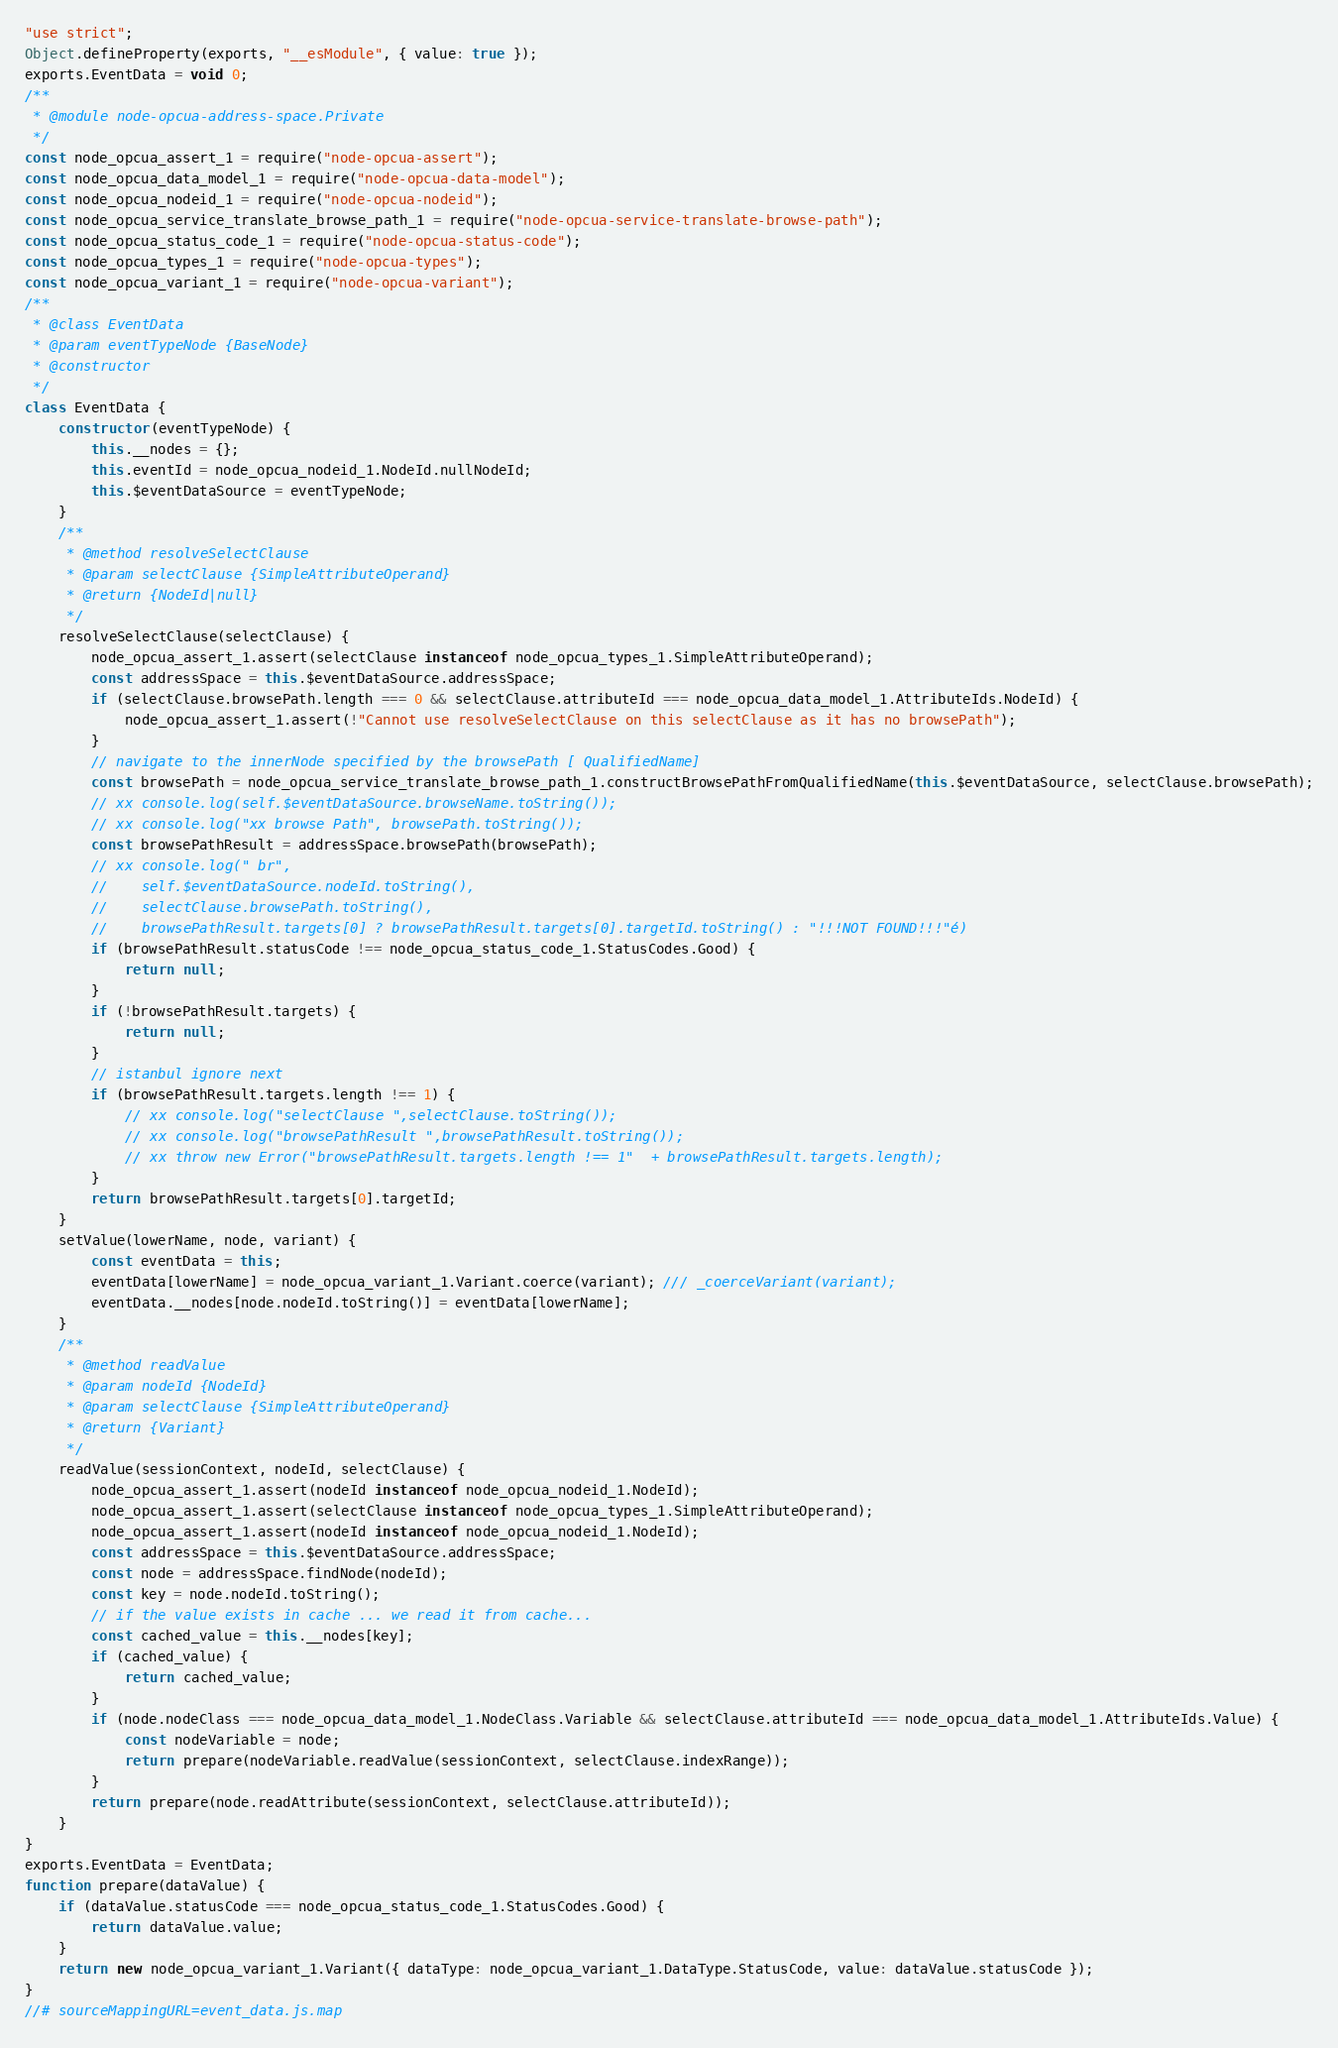Convert code to text. <code><loc_0><loc_0><loc_500><loc_500><_JavaScript_>"use strict";
Object.defineProperty(exports, "__esModule", { value: true });
exports.EventData = void 0;
/**
 * @module node-opcua-address-space.Private
 */
const node_opcua_assert_1 = require("node-opcua-assert");
const node_opcua_data_model_1 = require("node-opcua-data-model");
const node_opcua_nodeid_1 = require("node-opcua-nodeid");
const node_opcua_service_translate_browse_path_1 = require("node-opcua-service-translate-browse-path");
const node_opcua_status_code_1 = require("node-opcua-status-code");
const node_opcua_types_1 = require("node-opcua-types");
const node_opcua_variant_1 = require("node-opcua-variant");
/**
 * @class EventData
 * @param eventTypeNode {BaseNode}
 * @constructor
 */
class EventData {
    constructor(eventTypeNode) {
        this.__nodes = {};
        this.eventId = node_opcua_nodeid_1.NodeId.nullNodeId;
        this.$eventDataSource = eventTypeNode;
    }
    /**
     * @method resolveSelectClause
     * @param selectClause {SimpleAttributeOperand}
     * @return {NodeId|null}
     */
    resolveSelectClause(selectClause) {
        node_opcua_assert_1.assert(selectClause instanceof node_opcua_types_1.SimpleAttributeOperand);
        const addressSpace = this.$eventDataSource.addressSpace;
        if (selectClause.browsePath.length === 0 && selectClause.attributeId === node_opcua_data_model_1.AttributeIds.NodeId) {
            node_opcua_assert_1.assert(!"Cannot use resolveSelectClause on this selectClause as it has no browsePath");
        }
        // navigate to the innerNode specified by the browsePath [ QualifiedName]
        const browsePath = node_opcua_service_translate_browse_path_1.constructBrowsePathFromQualifiedName(this.$eventDataSource, selectClause.browsePath);
        // xx console.log(self.$eventDataSource.browseName.toString());
        // xx console.log("xx browse Path", browsePath.toString());
        const browsePathResult = addressSpace.browsePath(browsePath);
        // xx console.log(" br",
        //    self.$eventDataSource.nodeId.toString(),
        //    selectClause.browsePath.toString(),
        //    browsePathResult.targets[0] ? browsePathResult.targets[0].targetId.toString() : "!!!NOT FOUND!!!"é)
        if (browsePathResult.statusCode !== node_opcua_status_code_1.StatusCodes.Good) {
            return null;
        }
        if (!browsePathResult.targets) {
            return null;
        }
        // istanbul ignore next
        if (browsePathResult.targets.length !== 1) {
            // xx console.log("selectClause ",selectClause.toString());
            // xx console.log("browsePathResult ",browsePathResult.toString());
            // xx throw new Error("browsePathResult.targets.length !== 1"  + browsePathResult.targets.length);
        }
        return browsePathResult.targets[0].targetId;
    }
    setValue(lowerName, node, variant) {
        const eventData = this;
        eventData[lowerName] = node_opcua_variant_1.Variant.coerce(variant); /// _coerceVariant(variant);
        eventData.__nodes[node.nodeId.toString()] = eventData[lowerName];
    }
    /**
     * @method readValue
     * @param nodeId {NodeId}
     * @param selectClause {SimpleAttributeOperand}
     * @return {Variant}
     */
    readValue(sessionContext, nodeId, selectClause) {
        node_opcua_assert_1.assert(nodeId instanceof node_opcua_nodeid_1.NodeId);
        node_opcua_assert_1.assert(selectClause instanceof node_opcua_types_1.SimpleAttributeOperand);
        node_opcua_assert_1.assert(nodeId instanceof node_opcua_nodeid_1.NodeId);
        const addressSpace = this.$eventDataSource.addressSpace;
        const node = addressSpace.findNode(nodeId);
        const key = node.nodeId.toString();
        // if the value exists in cache ... we read it from cache...
        const cached_value = this.__nodes[key];
        if (cached_value) {
            return cached_value;
        }
        if (node.nodeClass === node_opcua_data_model_1.NodeClass.Variable && selectClause.attributeId === node_opcua_data_model_1.AttributeIds.Value) {
            const nodeVariable = node;
            return prepare(nodeVariable.readValue(sessionContext, selectClause.indexRange));
        }
        return prepare(node.readAttribute(sessionContext, selectClause.attributeId));
    }
}
exports.EventData = EventData;
function prepare(dataValue) {
    if (dataValue.statusCode === node_opcua_status_code_1.StatusCodes.Good) {
        return dataValue.value;
    }
    return new node_opcua_variant_1.Variant({ dataType: node_opcua_variant_1.DataType.StatusCode, value: dataValue.statusCode });
}
//# sourceMappingURL=event_data.js.map</code> 